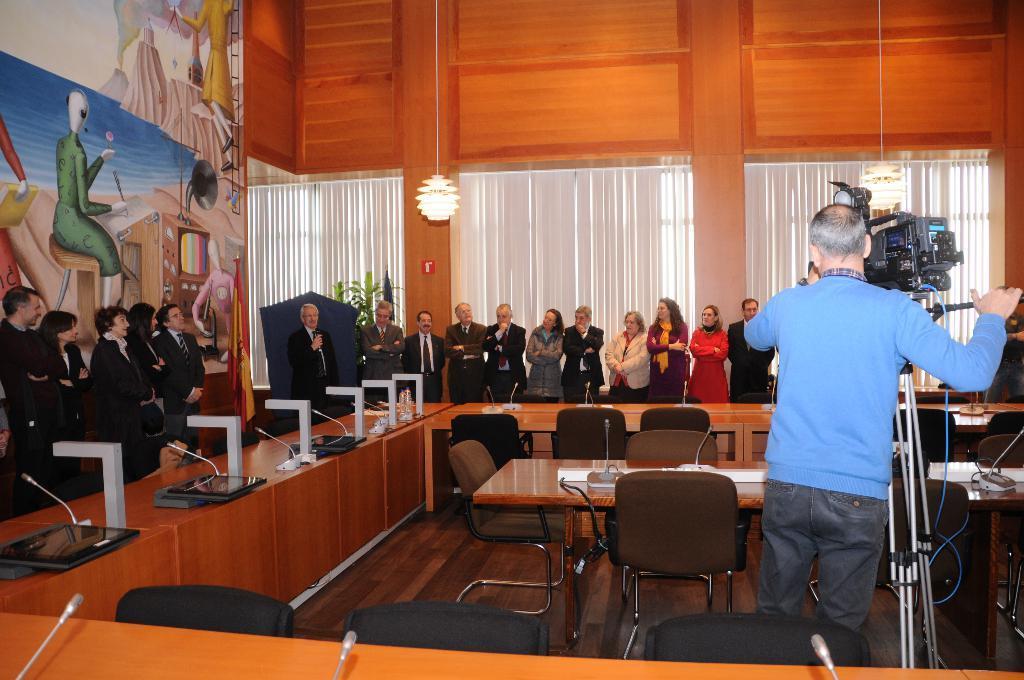In one or two sentences, can you explain what this image depicts? In this picture we can see all the persons standing in front of a table and on the table we can see miles and laptops. These are empty chairs. Here we can see one man holding a camera in his hand and recording. This is a light. This is a frame over a wall. We can see plants here. 